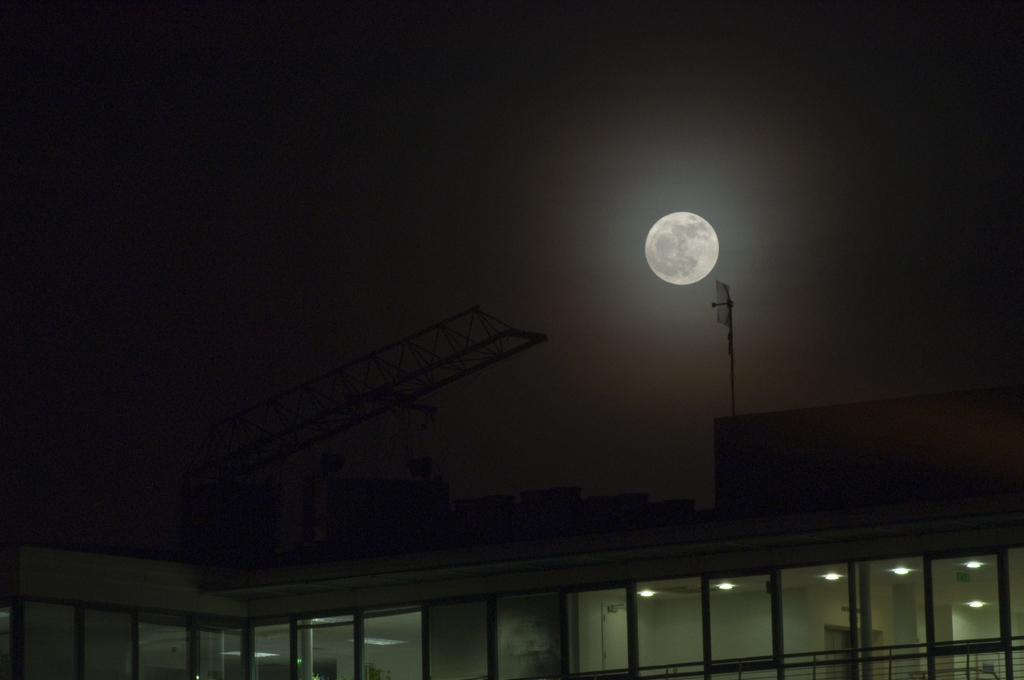What type of structure is located at the bottom of the image? There is a building at the bottom of the image. What is unique about the building's walls? The building has glass walls. What can be seen at the top of the image? The sky is visible at the top of the image. What celestial body is present in the sky? The moon is present in the sky. Can you tell me the credit score of the building in the image? There is no credit score associated with the building in the image, as buildings do not have credit scores. 